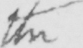Can you tell me what this handwritten text says? the 